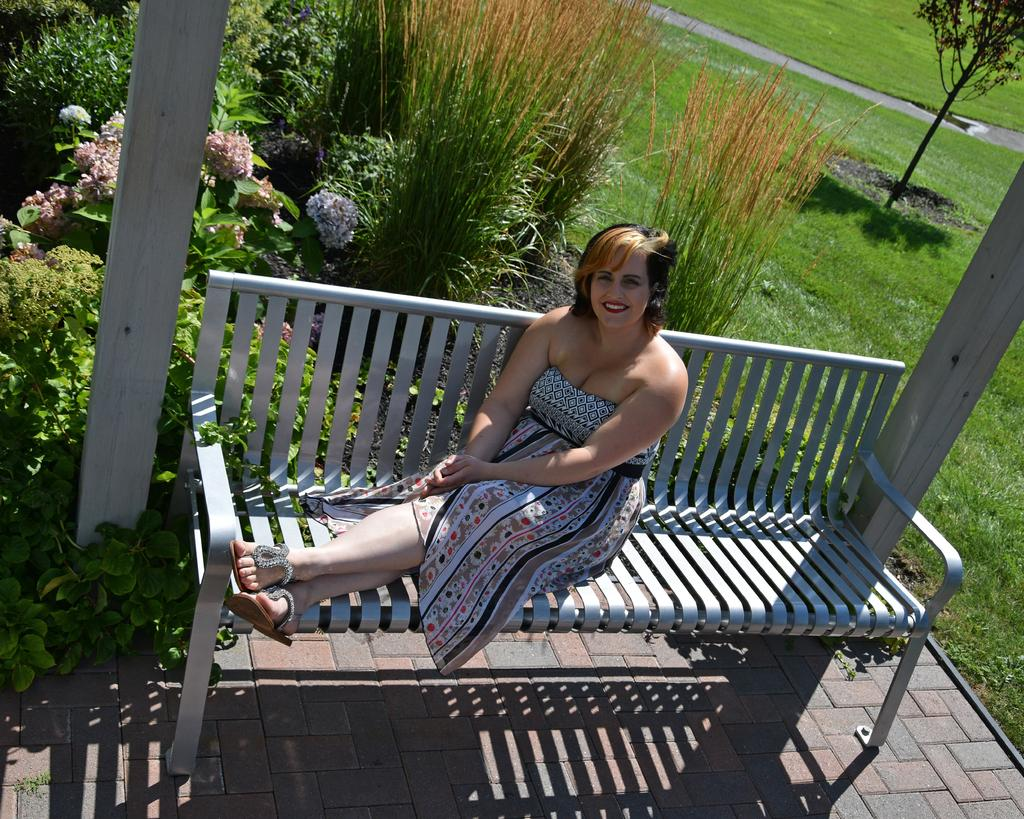Who is present in the image? There is a woman in the image. What is the woman doing in the image? The woman is sitting on a bench. What is the woman's facial expression in the image? The woman is smiling. What can be seen in the background of the image? There are plants and grass in the background of the image. What type of berry is the ghost eating in the image? There is no berry or ghost present in the image; it features a woman sitting on a bench and smiling. 